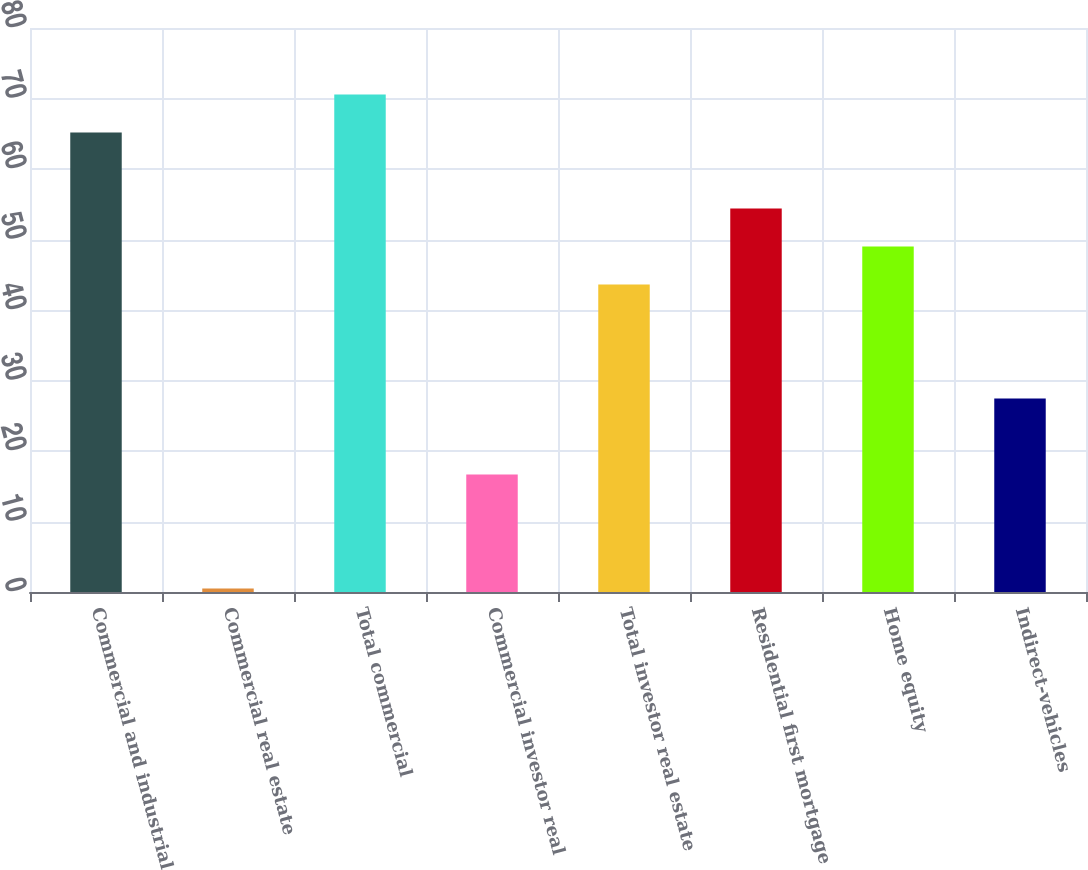Convert chart to OTSL. <chart><loc_0><loc_0><loc_500><loc_500><bar_chart><fcel>Commercial and industrial<fcel>Commercial real estate<fcel>Total commercial<fcel>Commercial investor real<fcel>Total investor real estate<fcel>Residential first mortgage<fcel>Home equity<fcel>Indirect-vehicles<nl><fcel>65.18<fcel>0.5<fcel>70.57<fcel>16.67<fcel>43.62<fcel>54.4<fcel>49.01<fcel>27.45<nl></chart> 